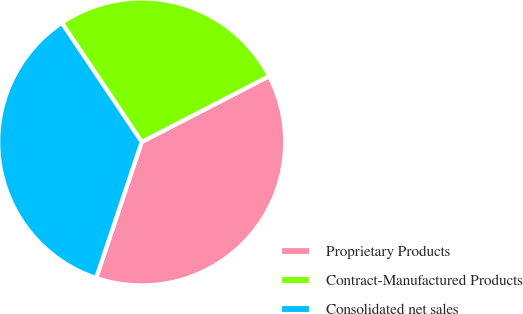Convert chart to OTSL. <chart><loc_0><loc_0><loc_500><loc_500><pie_chart><fcel>Proprietary Products<fcel>Contract-Manufactured Products<fcel>Consolidated net sales<nl><fcel>37.73%<fcel>26.82%<fcel>35.45%<nl></chart> 